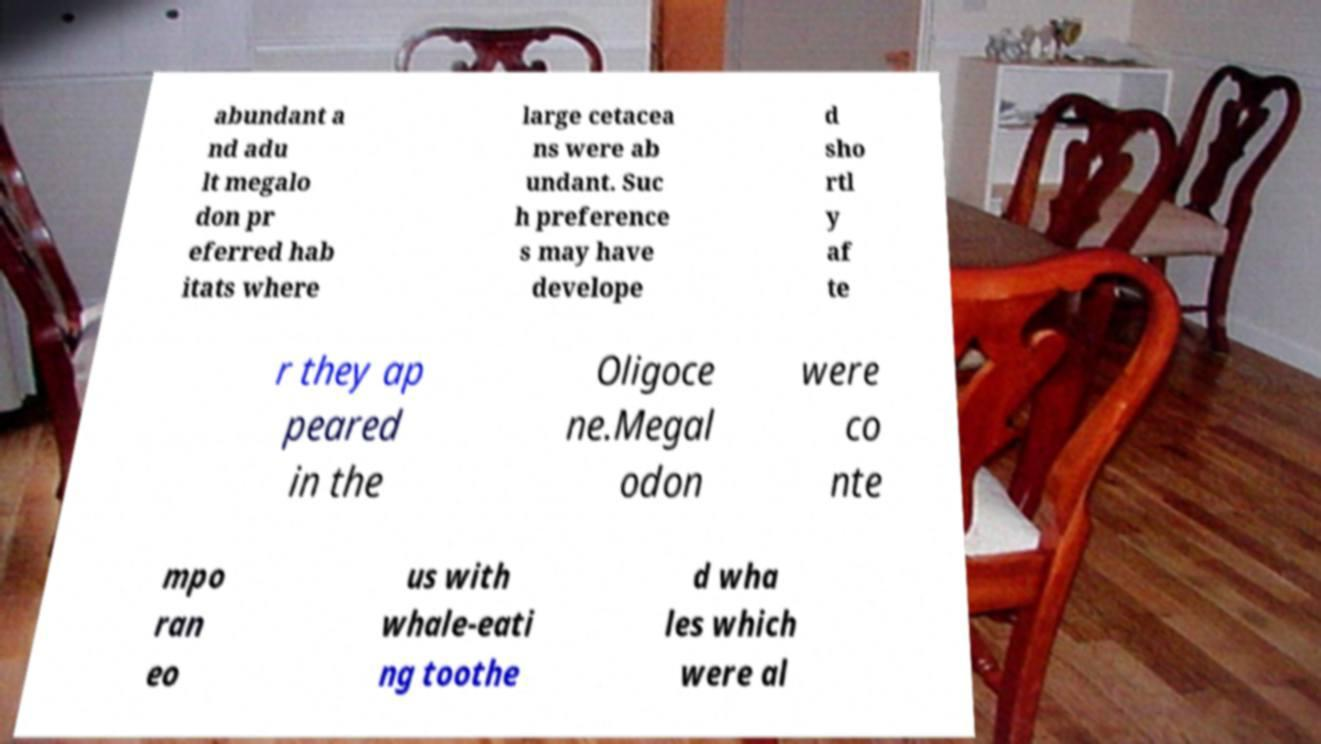Please read and relay the text visible in this image. What does it say? abundant a nd adu lt megalo don pr eferred hab itats where large cetacea ns were ab undant. Suc h preference s may have develope d sho rtl y af te r they ap peared in the Oligoce ne.Megal odon were co nte mpo ran eo us with whale-eati ng toothe d wha les which were al 